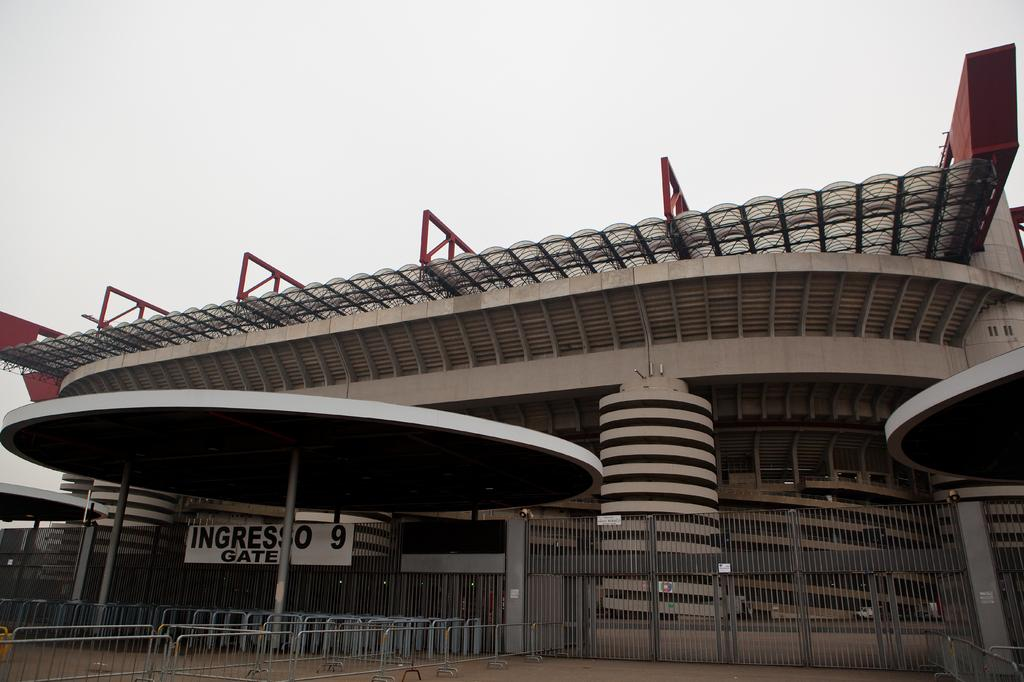What type of structure is present in the image? There is a building in the image. What else can be seen in the image besides the building? There are barricades in the image. What is visible in the sky in the image? Clouds are visible in the sky. What type of drug is being sold at the building in the image? There is no indication of any drug sales or presence in the image. The image only shows a building and barricades, with clouds visible in the sky. 